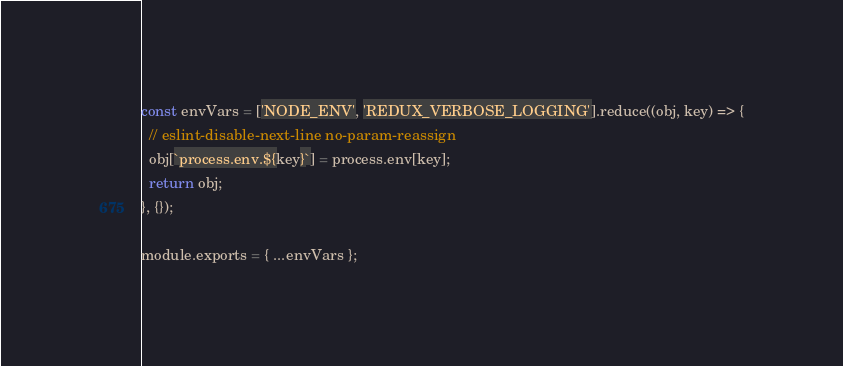<code> <loc_0><loc_0><loc_500><loc_500><_JavaScript_>const envVars = ['NODE_ENV', 'REDUX_VERBOSE_LOGGING'].reduce((obj, key) => {
  // eslint-disable-next-line no-param-reassign
  obj[`process.env.${key}`] = process.env[key];
  return obj;
}, {});

module.exports = { ...envVars };
</code> 